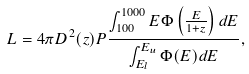Convert formula to latex. <formula><loc_0><loc_0><loc_500><loc_500>L = 4 \pi D ^ { 2 } ( z ) P \frac { \int _ { 1 0 0 } ^ { 1 0 0 0 } E \Phi \left ( \frac { E } { 1 + z } \right ) d E } { \int _ { E _ { l } } ^ { E _ { u } } \Phi ( E ) d E } ,</formula> 